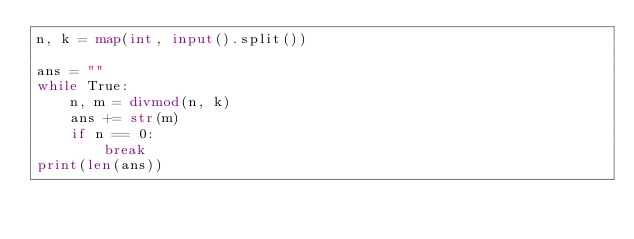<code> <loc_0><loc_0><loc_500><loc_500><_Python_>n, k = map(int, input().split())

ans = ""
while True:
    n, m = divmod(n, k)
    ans += str(m)
    if n == 0:
        break
print(len(ans))

</code> 